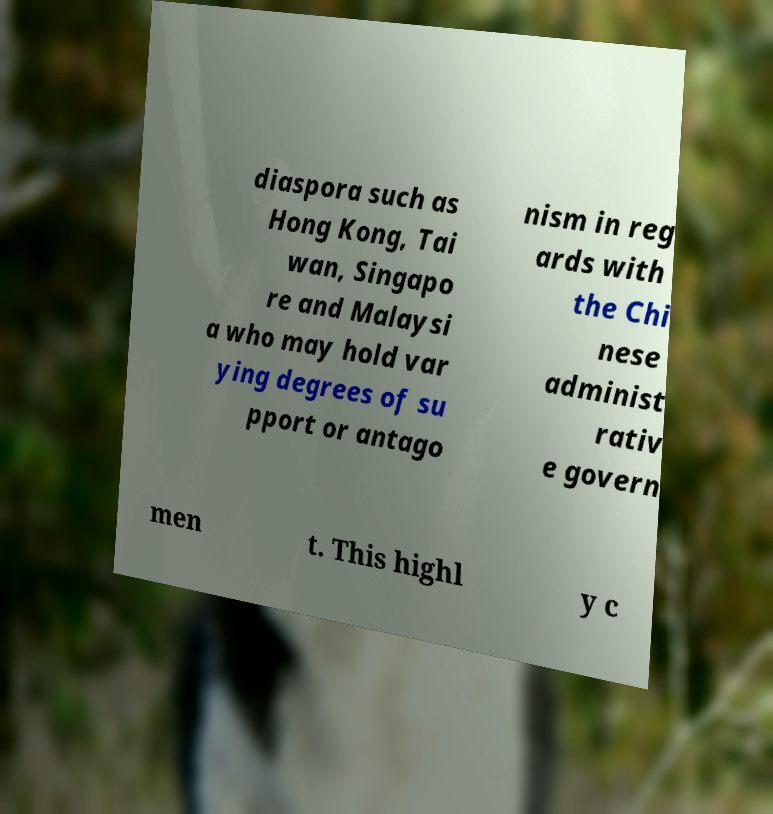Can you accurately transcribe the text from the provided image for me? diaspora such as Hong Kong, Tai wan, Singapo re and Malaysi a who may hold var ying degrees of su pport or antago nism in reg ards with the Chi nese administ rativ e govern men t. This highl y c 